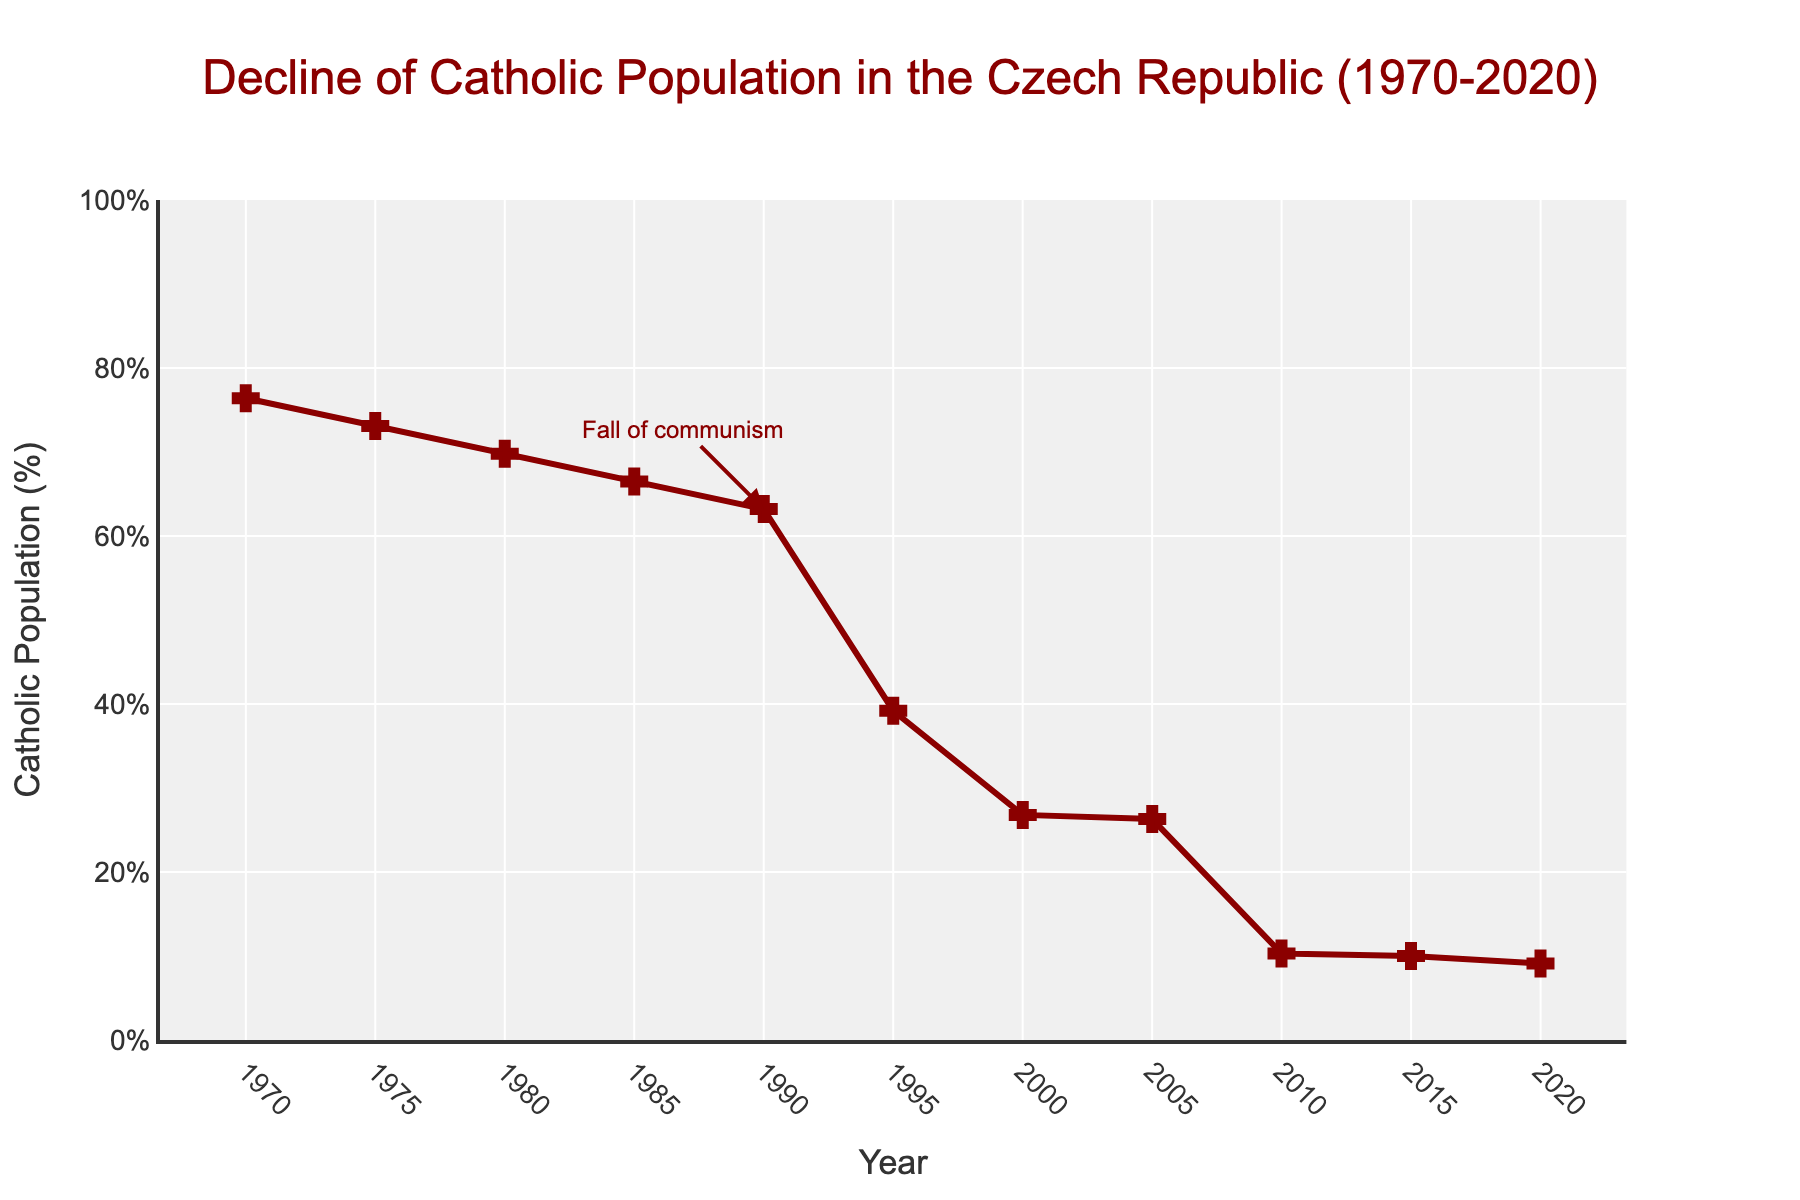What is the percentage change in the Catholic population from 1970 to 2020? The percentage in 1970 is 76.4%, and in 2020 it is 9.1%. The change is calculated by subtracting the latter from the former: 76.4 - 9.1 = 67.3%.
Answer: 67.3% How much did the Catholic population decrease between 1980 and 1995? The percentage in 1980 is 69.8%, and in 1995 it is 39.2%. The decrease is calculated by subtracting the latter from the former: 69.8 - 39.2 = 30.6%.
Answer: 30.6% During which decade did the Catholic population in the Czech Republic experience the largest decline? By examining the chart, the largest decline seems to occur between the 1980s and the 1990s. From around 69.8% in 1980 to 39.2% in 1995.
Answer: Between 1980 and 1995 What is the average Catholic population percentage over the entire period from 1970 to 2020? To find the average, sum all percentages and then divide by the number of data points (11): (76.4 + 73.1 + 69.8 + 66.5 + 63.2 + 39.2 + 26.8 + 26.3 + 10.3 + 10.0 + 9.1) / 11 = 43.0%.
Answer: 43.0% By how many percentage points did the Catholic population decrease immediately following the fall of communism around 1990? In 1990, the percentage was 63.2%, and by 1995 it was 39.2%. The decrease is 63.2 - 39.2 = 24%.
Answer: 24% Compare the Catholic population percentage in 1970 with that in 2010. Which year had a higher percentage, and by how much? 1970 had a percentage of 76.4%, and 2010 had 10.3%. The difference is 76.4 - 10.3 = 66.1%. So, 1970 had a higher percentage by 66.1%.
Answer: 1970 by 66.1% At what rate did the Catholic population decline per decade from 1990 to 2020? From 1990 (63.2%) to 2020 (9.1%), the total period is 30 years. The total decrease is 63.2 - 9.1 = 54.1%. Per decade (10 years), the decline rate is 54.1% / 3 = 18.03%.
Answer: 18.03% per decade What visual attribute is used to highlight the "Fall of communism" annotation? The figure uses an arrowhead with a red color pointing to the year 1990 with the text "Fall of communism".
Answer: Red arrow with text What was the percentage of the Catholic population in 1985 and how did it compare with 2000? The percentage in 1985 was 66.5%, and in 2000, it was 26.8%. The difference is 66.5 - 26.8 = 39.7%. 1985 had a higher percentage by 39.7%.
Answer: 1985 by 39.7% Estimate the trend of the Catholic population decline by visual inspection between the years 2005 and 2020. The percentage in 2005 was 26.3% and consistently decreased over the years, reaching 9.1% by 2020. The trend shows a steady decline.
Answer: Steady decline 